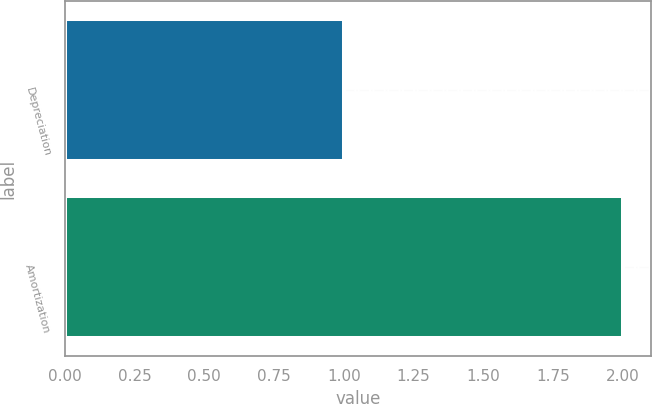<chart> <loc_0><loc_0><loc_500><loc_500><bar_chart><fcel>Depreciation<fcel>Amortization<nl><fcel>1<fcel>2<nl></chart> 